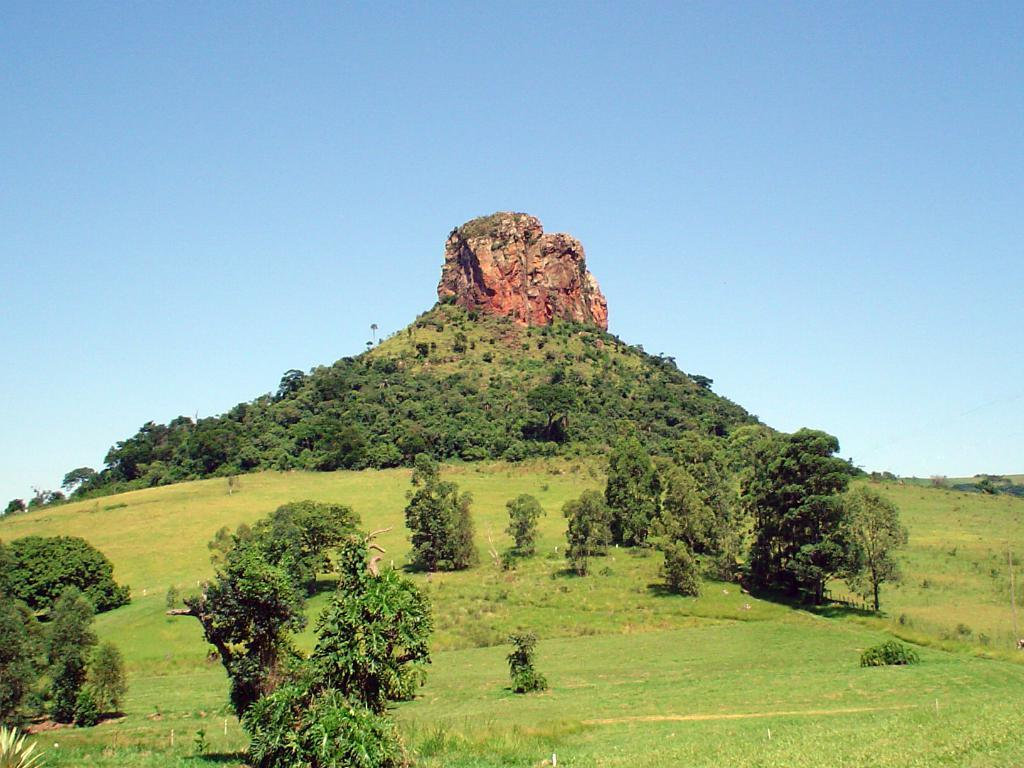Where was the image taken? The image was taken on a hill. What can be seen on the hill in the image? There are trees and grass on the hill, as well as a rock in the center. What is visible at the top of the image? The sky is visible at the top of the image. What type of bushes can be seen growing near the rock on the hill? There are no bushes visible in the image; only trees and grass are present on the hill. 